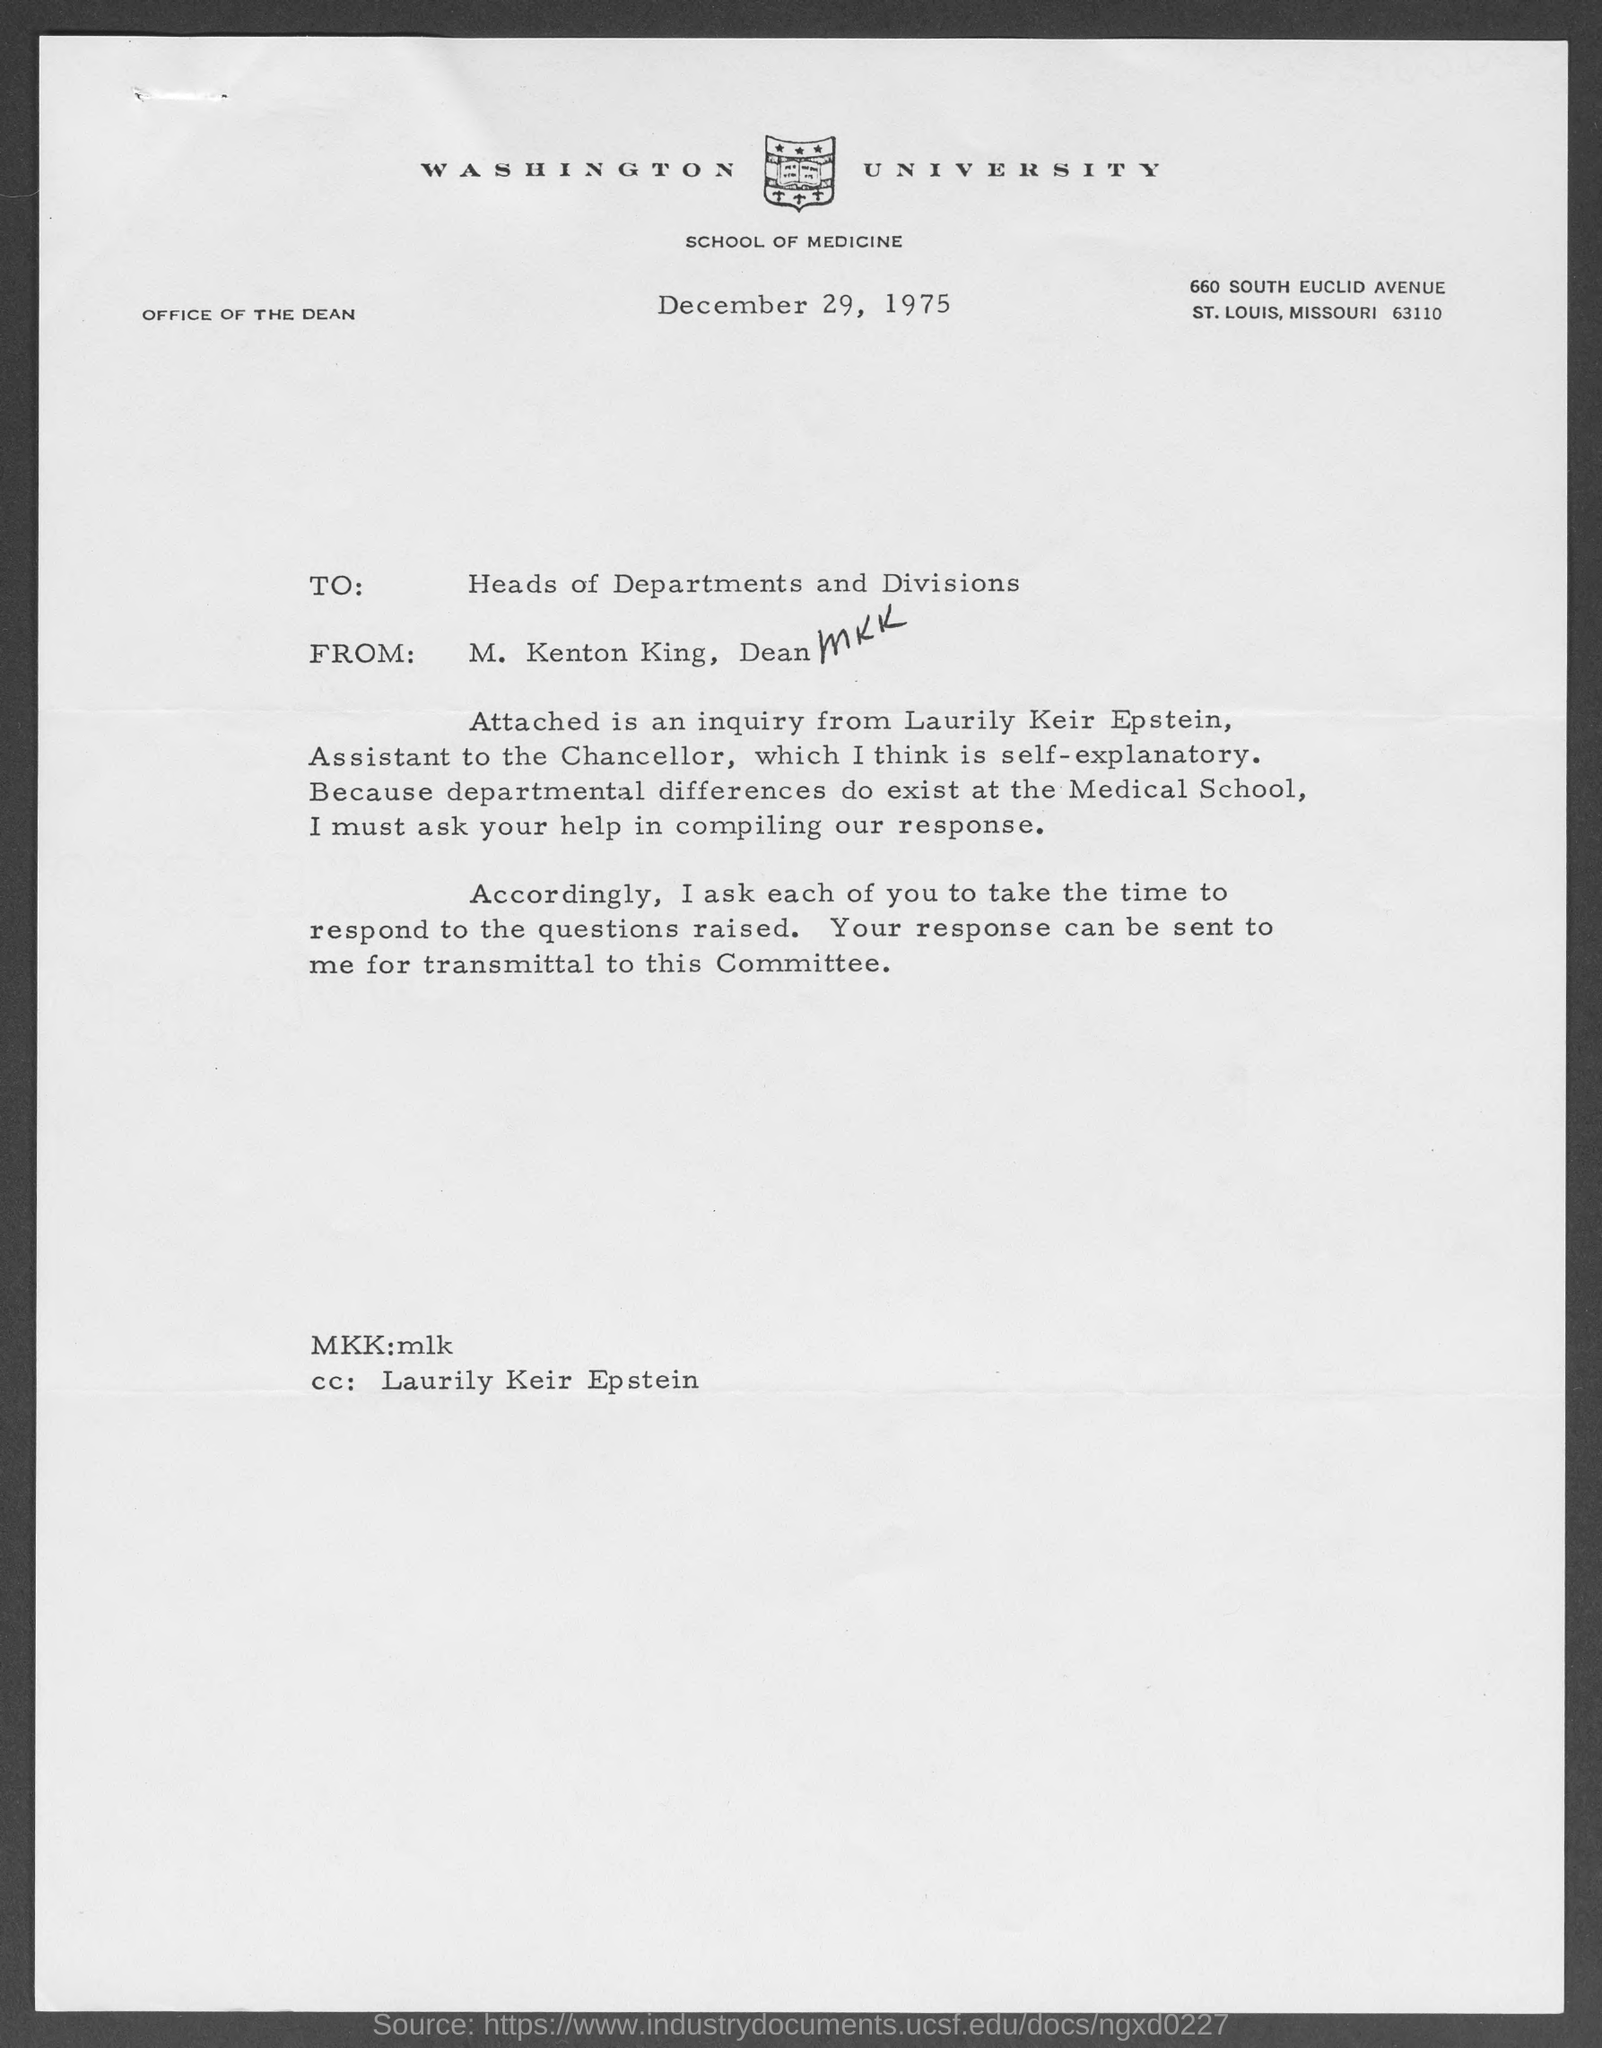What is avenue address of washington university school of medicine ?
Offer a very short reply. 660 South Euclid Avenue. When is the letter dated ?
Make the answer very short. December 29, 1975. Who wrote this letter?
Your answer should be compact. M. Kenton King. What is the position of m. kenton king ?
Offer a terse response. Dean. 